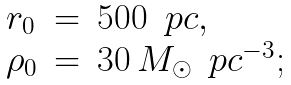<formula> <loc_0><loc_0><loc_500><loc_500>\begin{array} { l l l } r _ { 0 } & = & 5 0 0 \, \ p c , \\ \rho _ { 0 } & = & 3 0 \, M _ { \odot } \, \ p c ^ { - 3 } ; \\ \end{array}</formula> 